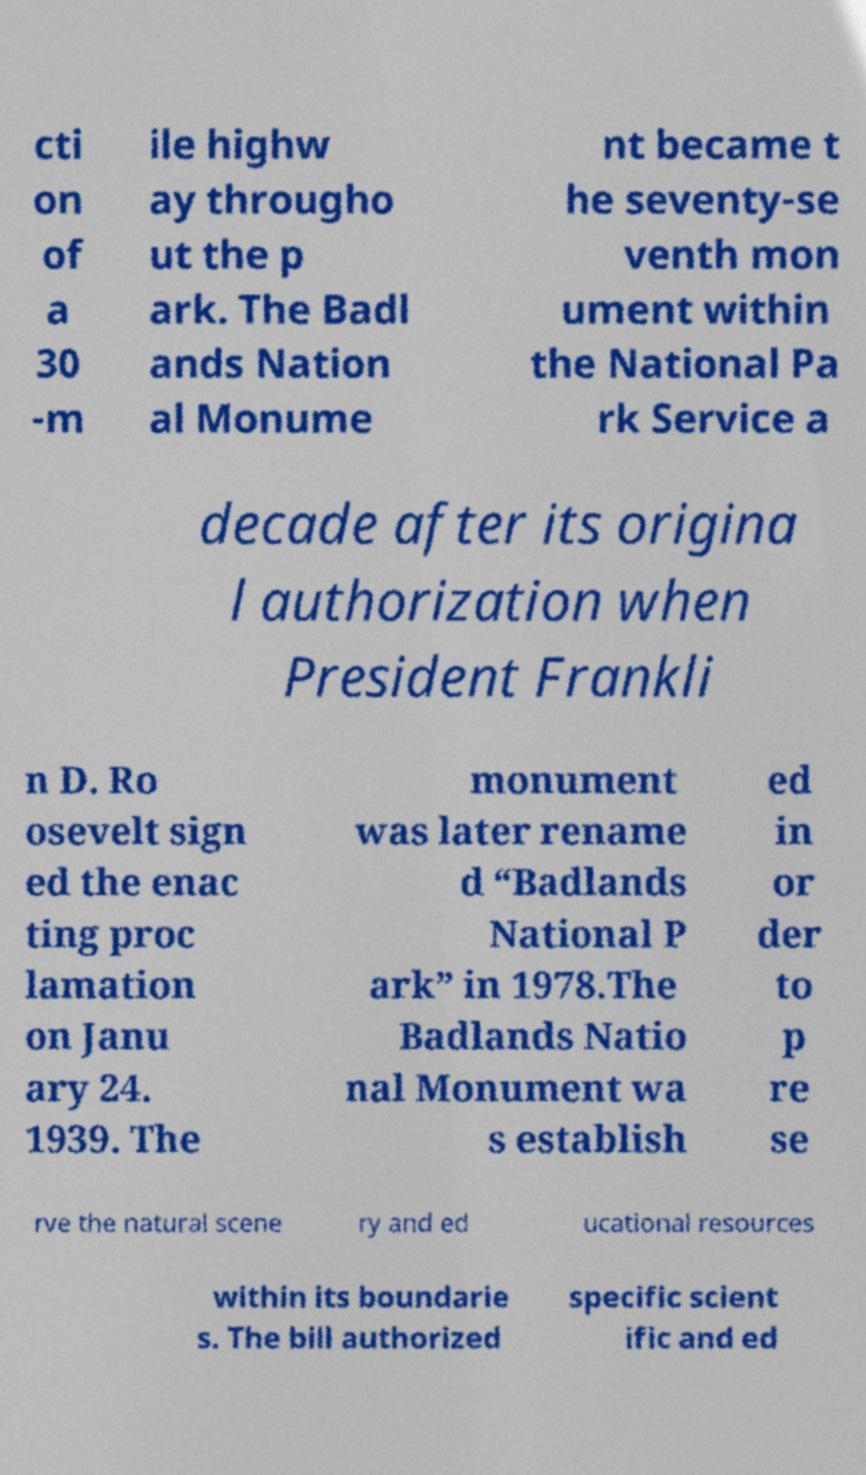There's text embedded in this image that I need extracted. Can you transcribe it verbatim? cti on of a 30 -m ile highw ay througho ut the p ark. The Badl ands Nation al Monume nt became t he seventy-se venth mon ument within the National Pa rk Service a decade after its origina l authorization when President Frankli n D. Ro osevelt sign ed the enac ting proc lamation on Janu ary 24. 1939. The monument was later rename d “Badlands National P ark” in 1978.The Badlands Natio nal Monument wa s establish ed in or der to p re se rve the natural scene ry and ed ucational resources within its boundarie s. The bill authorized specific scient ific and ed 